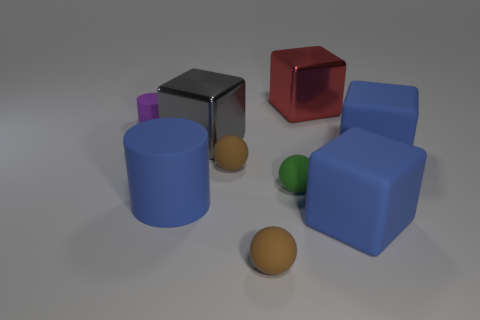Which objects in the image are closest to the camera? The two objects closest to the camera are a reddish-brown sphere and a cyan matte cylinder. What can you tell me about the lighting in the scene? The lighting in the image seems to come from above, casting soft shadows directly beneath the objects, suggesting a diffuse light source that creates a serene atmosphere. 